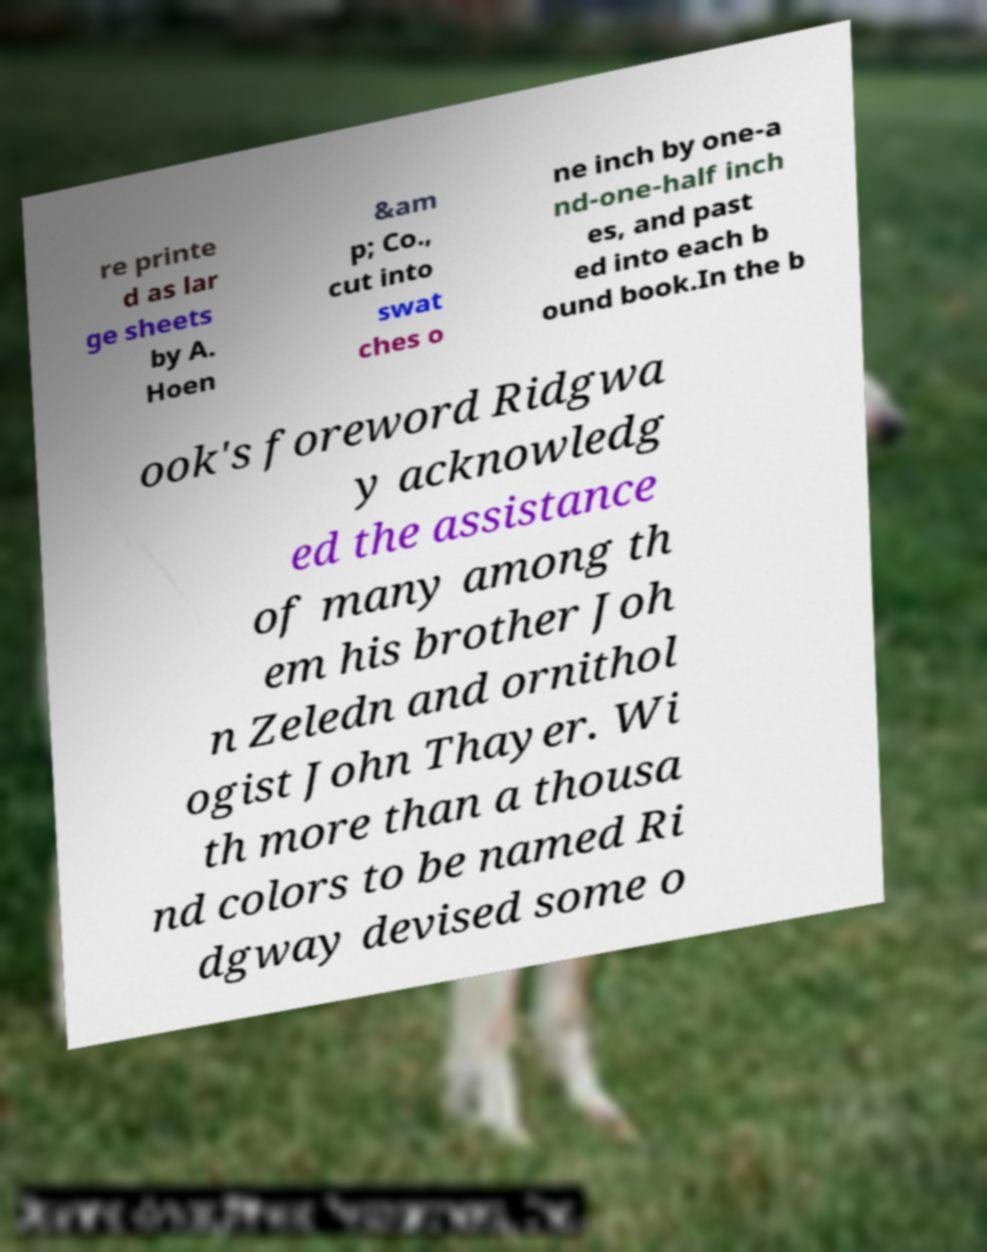Can you accurately transcribe the text from the provided image for me? re printe d as lar ge sheets by A. Hoen &am p; Co., cut into swat ches o ne inch by one-a nd-one-half inch es, and past ed into each b ound book.In the b ook's foreword Ridgwa y acknowledg ed the assistance of many among th em his brother Joh n Zeledn and ornithol ogist John Thayer. Wi th more than a thousa nd colors to be named Ri dgway devised some o 